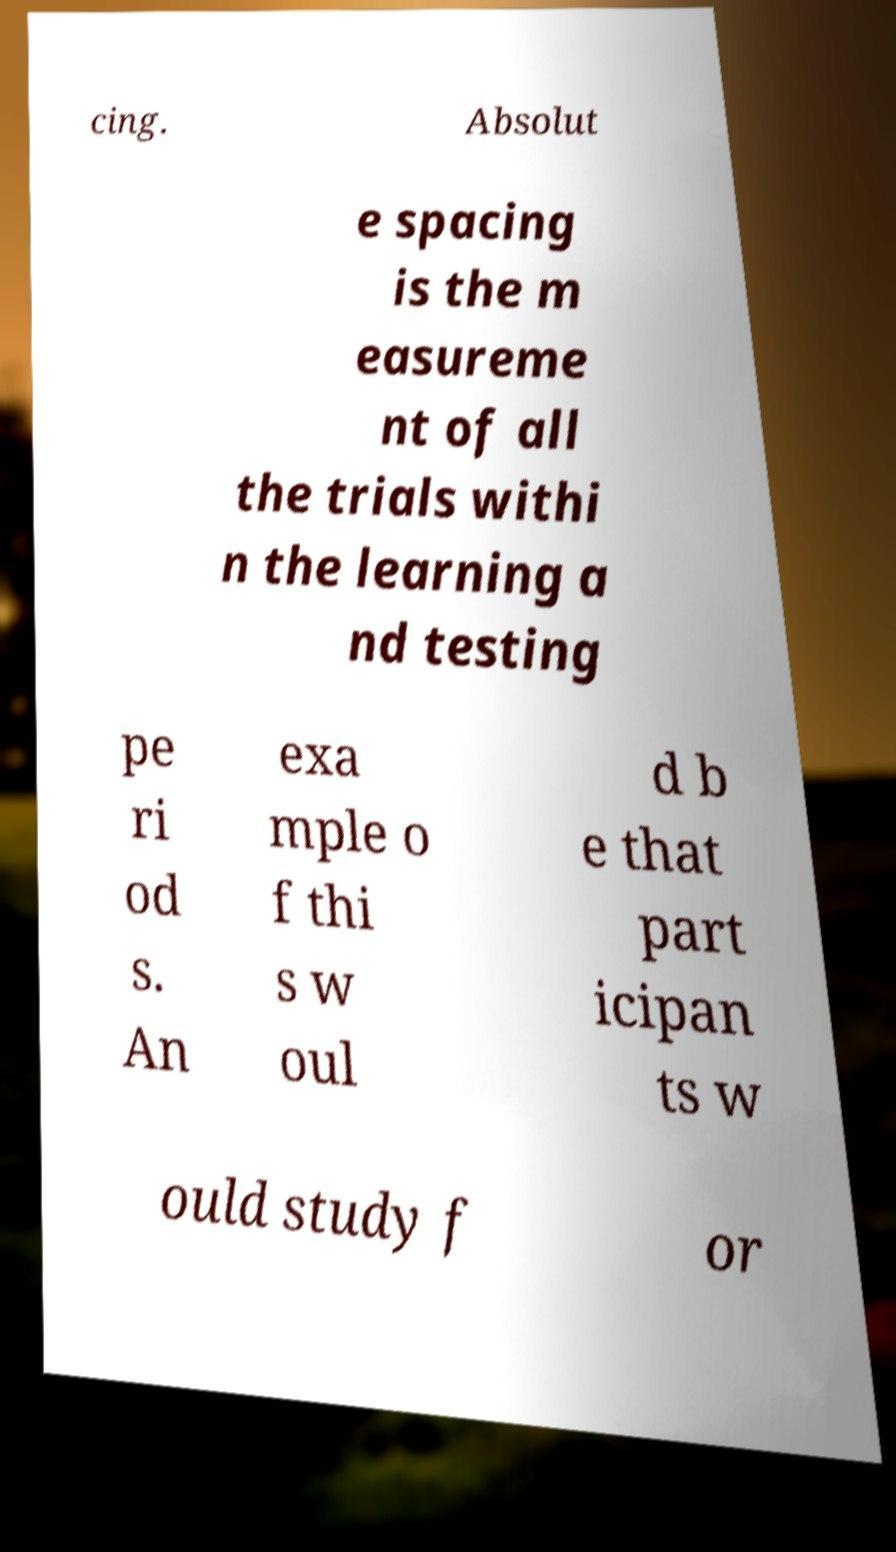Could you extract and type out the text from this image? cing. Absolut e spacing is the m easureme nt of all the trials withi n the learning a nd testing pe ri od s. An exa mple o f thi s w oul d b e that part icipan ts w ould study f or 